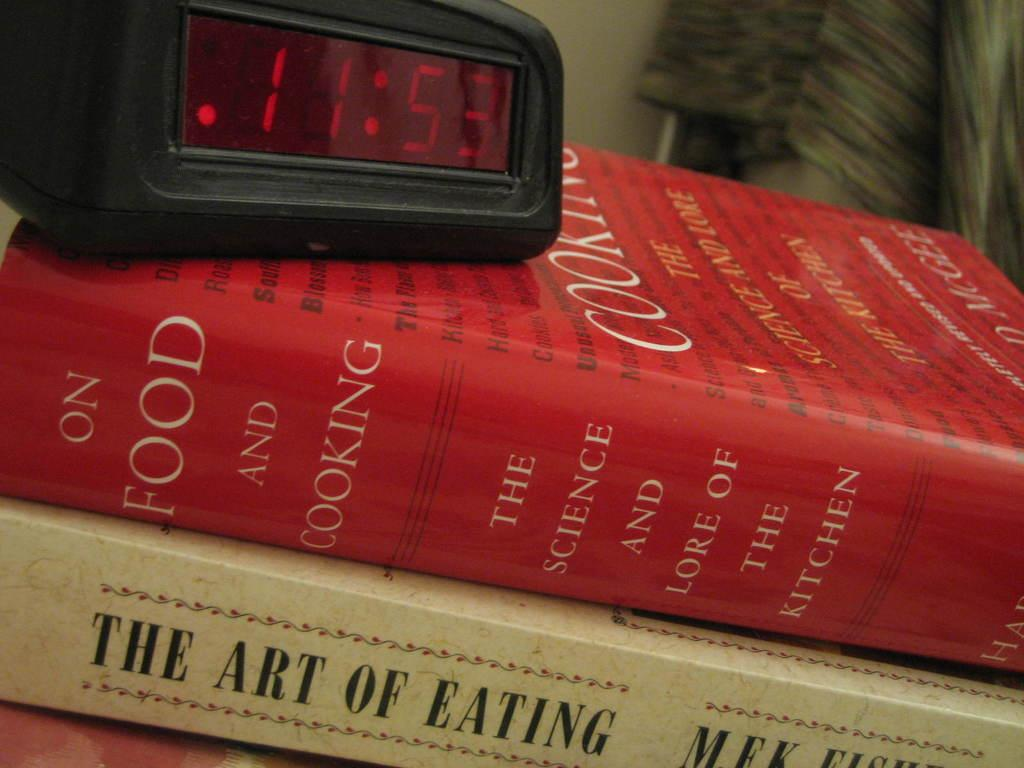<image>
Create a compact narrative representing the image presented. An alarm clock showing 11:53 is on a stack of books about cooking. 